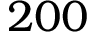<formula> <loc_0><loc_0><loc_500><loc_500>2 0 0</formula> 